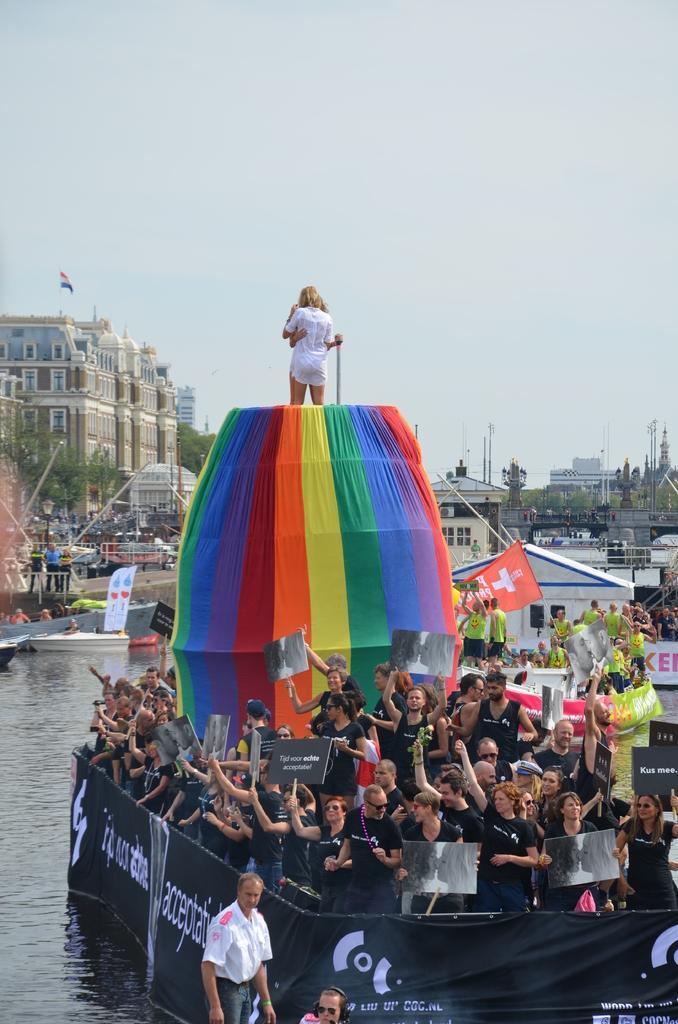How would you summarize this image in a sentence or two? In this image I can see the water and on the surface of the water I can see a ship which is black in color and on the ship I can see number of persons wearing black colored dresses. In the background I can see few trees, few buildings, few boats on the surface of the water and the sky. 